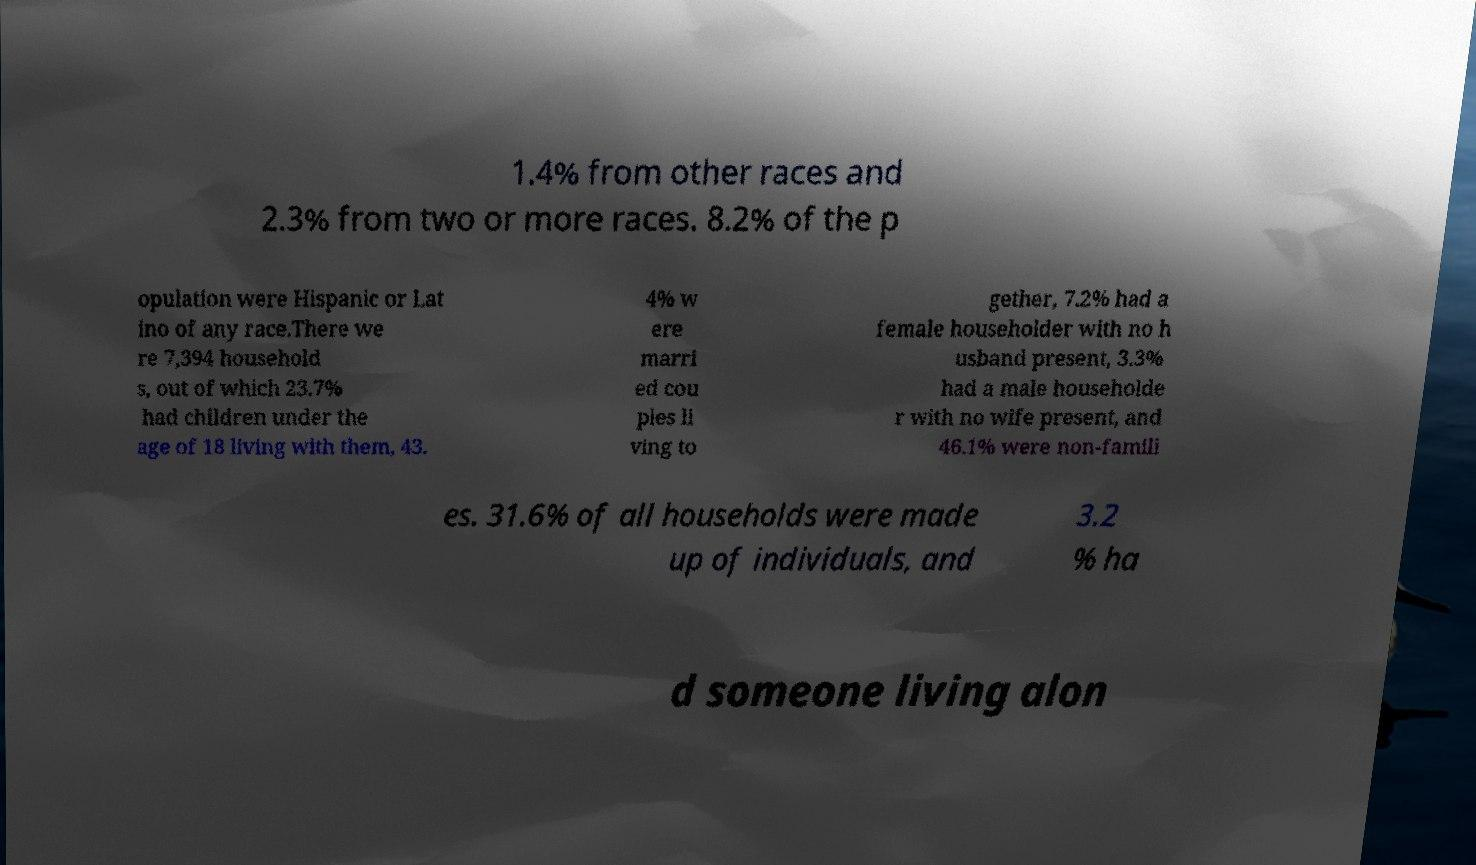For documentation purposes, I need the text within this image transcribed. Could you provide that? 1.4% from other races and 2.3% from two or more races. 8.2% of the p opulation were Hispanic or Lat ino of any race.There we re 7,394 household s, out of which 23.7% had children under the age of 18 living with them, 43. 4% w ere marri ed cou ples li ving to gether, 7.2% had a female householder with no h usband present, 3.3% had a male householde r with no wife present, and 46.1% were non-famili es. 31.6% of all households were made up of individuals, and 3.2 % ha d someone living alon 